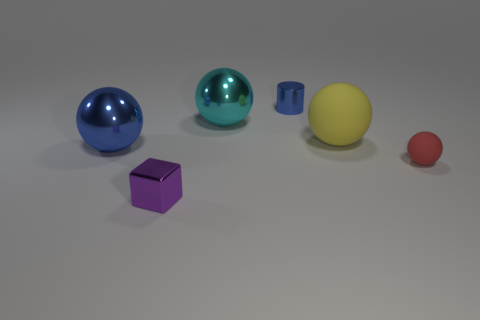Is the number of shiny cubes that are behind the tiny block the same as the number of large metallic objects on the left side of the blue sphere?
Your answer should be compact. Yes. There is a big metal thing that is the same color as the cylinder; what shape is it?
Provide a short and direct response. Sphere. Do the big thing that is in front of the large rubber sphere and the tiny metal thing that is right of the purple metallic block have the same color?
Your response must be concise. Yes. Is the number of large spheres that are to the right of the blue cylinder greater than the number of small green metallic spheres?
Ensure brevity in your answer.  Yes. What is the large yellow sphere made of?
Provide a short and direct response. Rubber. The large blue thing that is made of the same material as the cyan ball is what shape?
Offer a terse response. Sphere. There is a matte thing behind the metallic sphere in front of the cyan shiny thing; what size is it?
Give a very brief answer. Large. The tiny metal object that is to the left of the large cyan thing is what color?
Ensure brevity in your answer.  Purple. Is there a metallic thing that has the same shape as the yellow matte thing?
Provide a succinct answer. Yes. Are there fewer blue metallic objects that are in front of the metal cube than red matte things that are to the right of the tiny blue metal cylinder?
Keep it short and to the point. Yes. 